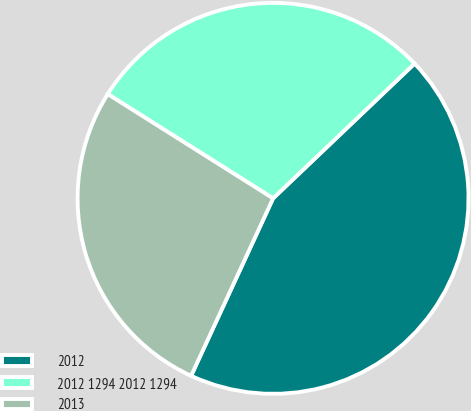Convert chart to OTSL. <chart><loc_0><loc_0><loc_500><loc_500><pie_chart><fcel>2012<fcel>2012 1294 2012 1294<fcel>2013<nl><fcel>44.0%<fcel>28.93%<fcel>27.07%<nl></chart> 